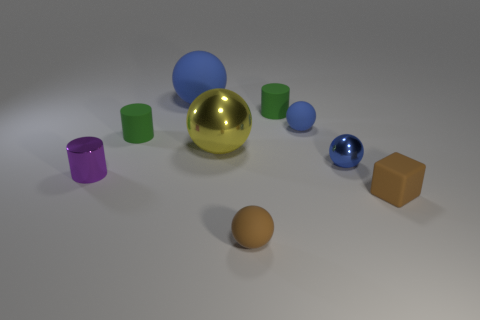Subtract all green cubes. How many blue balls are left? 3 Subtract all yellow balls. How many balls are left? 4 Subtract all blue metal balls. How many balls are left? 4 Subtract 1 cylinders. How many cylinders are left? 2 Subtract all cylinders. How many objects are left? 6 Subtract all red balls. Subtract all purple cubes. How many balls are left? 5 Add 6 large metallic objects. How many large metallic objects exist? 7 Subtract 0 gray balls. How many objects are left? 9 Subtract all rubber things. Subtract all large rubber things. How many objects are left? 2 Add 8 small brown matte blocks. How many small brown matte blocks are left? 9 